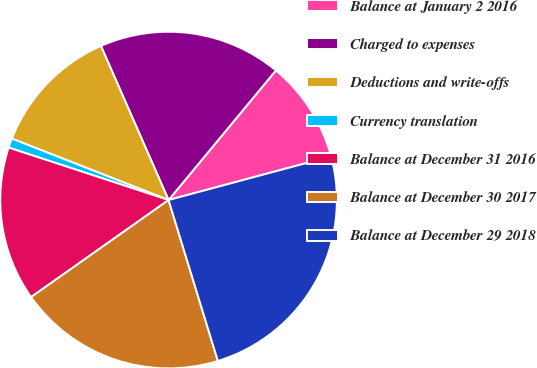Convert chart to OTSL. <chart><loc_0><loc_0><loc_500><loc_500><pie_chart><fcel>Balance at January 2 2016<fcel>Charged to expenses<fcel>Deductions and write-offs<fcel>Currency translation<fcel>Balance at December 31 2016<fcel>Balance at December 30 2017<fcel>Balance at December 29 2018<nl><fcel>9.82%<fcel>17.59%<fcel>12.47%<fcel>0.9%<fcel>14.83%<fcel>19.95%<fcel>24.44%<nl></chart> 